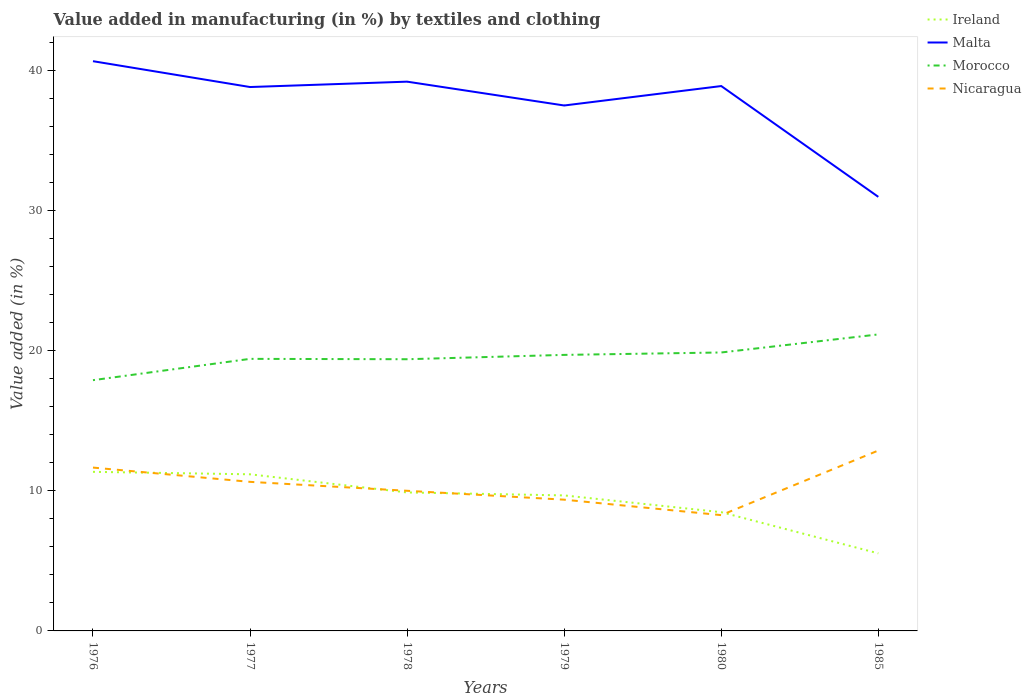How many different coloured lines are there?
Make the answer very short. 4. Does the line corresponding to Ireland intersect with the line corresponding to Malta?
Offer a terse response. No. Is the number of lines equal to the number of legend labels?
Keep it short and to the point. Yes. Across all years, what is the maximum percentage of value added in manufacturing by textiles and clothing in Nicaragua?
Provide a succinct answer. 8.27. In which year was the percentage of value added in manufacturing by textiles and clothing in Ireland maximum?
Ensure brevity in your answer.  1985. What is the total percentage of value added in manufacturing by textiles and clothing in Nicaragua in the graph?
Your response must be concise. 1.74. What is the difference between the highest and the second highest percentage of value added in manufacturing by textiles and clothing in Malta?
Give a very brief answer. 9.69. Does the graph contain any zero values?
Keep it short and to the point. No. Does the graph contain grids?
Your answer should be compact. No. Where does the legend appear in the graph?
Your answer should be compact. Top right. How are the legend labels stacked?
Ensure brevity in your answer.  Vertical. What is the title of the graph?
Your response must be concise. Value added in manufacturing (in %) by textiles and clothing. Does "Benin" appear as one of the legend labels in the graph?
Your answer should be compact. No. What is the label or title of the X-axis?
Provide a succinct answer. Years. What is the label or title of the Y-axis?
Make the answer very short. Value added (in %). What is the Value added (in %) of Ireland in 1976?
Your response must be concise. 11.36. What is the Value added (in %) of Malta in 1976?
Provide a short and direct response. 40.68. What is the Value added (in %) in Morocco in 1976?
Provide a short and direct response. 17.9. What is the Value added (in %) in Nicaragua in 1976?
Your answer should be very brief. 11.66. What is the Value added (in %) in Ireland in 1977?
Give a very brief answer. 11.18. What is the Value added (in %) in Malta in 1977?
Your answer should be very brief. 38.84. What is the Value added (in %) of Morocco in 1977?
Offer a very short reply. 19.43. What is the Value added (in %) of Nicaragua in 1977?
Your response must be concise. 10.64. What is the Value added (in %) in Ireland in 1978?
Make the answer very short. 9.89. What is the Value added (in %) in Malta in 1978?
Your answer should be compact. 39.22. What is the Value added (in %) in Morocco in 1978?
Offer a terse response. 19.4. What is the Value added (in %) in Nicaragua in 1978?
Give a very brief answer. 10.01. What is the Value added (in %) of Ireland in 1979?
Keep it short and to the point. 9.68. What is the Value added (in %) of Malta in 1979?
Your answer should be compact. 37.52. What is the Value added (in %) of Morocco in 1979?
Make the answer very short. 19.71. What is the Value added (in %) in Nicaragua in 1979?
Make the answer very short. 9.37. What is the Value added (in %) in Ireland in 1980?
Offer a very short reply. 8.48. What is the Value added (in %) of Malta in 1980?
Your response must be concise. 38.91. What is the Value added (in %) of Morocco in 1980?
Your response must be concise. 19.88. What is the Value added (in %) of Nicaragua in 1980?
Offer a very short reply. 8.27. What is the Value added (in %) in Ireland in 1985?
Ensure brevity in your answer.  5.54. What is the Value added (in %) in Malta in 1985?
Make the answer very short. 30.99. What is the Value added (in %) of Morocco in 1985?
Provide a succinct answer. 21.17. What is the Value added (in %) of Nicaragua in 1985?
Ensure brevity in your answer.  12.88. Across all years, what is the maximum Value added (in %) in Ireland?
Provide a short and direct response. 11.36. Across all years, what is the maximum Value added (in %) of Malta?
Ensure brevity in your answer.  40.68. Across all years, what is the maximum Value added (in %) in Morocco?
Ensure brevity in your answer.  21.17. Across all years, what is the maximum Value added (in %) in Nicaragua?
Ensure brevity in your answer.  12.88. Across all years, what is the minimum Value added (in %) in Ireland?
Make the answer very short. 5.54. Across all years, what is the minimum Value added (in %) of Malta?
Your response must be concise. 30.99. Across all years, what is the minimum Value added (in %) of Morocco?
Provide a succinct answer. 17.9. Across all years, what is the minimum Value added (in %) of Nicaragua?
Provide a short and direct response. 8.27. What is the total Value added (in %) in Ireland in the graph?
Offer a very short reply. 56.12. What is the total Value added (in %) in Malta in the graph?
Your answer should be compact. 226.15. What is the total Value added (in %) of Morocco in the graph?
Your answer should be compact. 117.49. What is the total Value added (in %) in Nicaragua in the graph?
Your answer should be very brief. 62.83. What is the difference between the Value added (in %) in Ireland in 1976 and that in 1977?
Keep it short and to the point. 0.18. What is the difference between the Value added (in %) in Malta in 1976 and that in 1977?
Give a very brief answer. 1.85. What is the difference between the Value added (in %) of Morocco in 1976 and that in 1977?
Offer a terse response. -1.52. What is the difference between the Value added (in %) of Nicaragua in 1976 and that in 1977?
Your response must be concise. 1.02. What is the difference between the Value added (in %) of Ireland in 1976 and that in 1978?
Your answer should be very brief. 1.47. What is the difference between the Value added (in %) of Malta in 1976 and that in 1978?
Offer a very short reply. 1.46. What is the difference between the Value added (in %) in Morocco in 1976 and that in 1978?
Your answer should be compact. -1.5. What is the difference between the Value added (in %) of Nicaragua in 1976 and that in 1978?
Ensure brevity in your answer.  1.66. What is the difference between the Value added (in %) in Ireland in 1976 and that in 1979?
Provide a succinct answer. 1.68. What is the difference between the Value added (in %) of Malta in 1976 and that in 1979?
Offer a very short reply. 3.16. What is the difference between the Value added (in %) of Morocco in 1976 and that in 1979?
Offer a very short reply. -1.81. What is the difference between the Value added (in %) of Nicaragua in 1976 and that in 1979?
Offer a very short reply. 2.29. What is the difference between the Value added (in %) in Ireland in 1976 and that in 1980?
Your answer should be very brief. 2.88. What is the difference between the Value added (in %) in Malta in 1976 and that in 1980?
Give a very brief answer. 1.78. What is the difference between the Value added (in %) in Morocco in 1976 and that in 1980?
Offer a terse response. -1.98. What is the difference between the Value added (in %) in Nicaragua in 1976 and that in 1980?
Your answer should be compact. 3.39. What is the difference between the Value added (in %) in Ireland in 1976 and that in 1985?
Offer a very short reply. 5.82. What is the difference between the Value added (in %) of Malta in 1976 and that in 1985?
Keep it short and to the point. 9.69. What is the difference between the Value added (in %) in Morocco in 1976 and that in 1985?
Make the answer very short. -3.27. What is the difference between the Value added (in %) of Nicaragua in 1976 and that in 1985?
Keep it short and to the point. -1.22. What is the difference between the Value added (in %) of Ireland in 1977 and that in 1978?
Offer a very short reply. 1.3. What is the difference between the Value added (in %) of Malta in 1977 and that in 1978?
Offer a terse response. -0.38. What is the difference between the Value added (in %) in Morocco in 1977 and that in 1978?
Offer a very short reply. 0.03. What is the difference between the Value added (in %) in Nicaragua in 1977 and that in 1978?
Your answer should be very brief. 0.64. What is the difference between the Value added (in %) in Ireland in 1977 and that in 1979?
Ensure brevity in your answer.  1.51. What is the difference between the Value added (in %) of Malta in 1977 and that in 1979?
Your answer should be compact. 1.32. What is the difference between the Value added (in %) of Morocco in 1977 and that in 1979?
Your response must be concise. -0.28. What is the difference between the Value added (in %) of Nicaragua in 1977 and that in 1979?
Keep it short and to the point. 1.27. What is the difference between the Value added (in %) in Ireland in 1977 and that in 1980?
Give a very brief answer. 2.7. What is the difference between the Value added (in %) in Malta in 1977 and that in 1980?
Offer a terse response. -0.07. What is the difference between the Value added (in %) of Morocco in 1977 and that in 1980?
Your answer should be compact. -0.46. What is the difference between the Value added (in %) of Nicaragua in 1977 and that in 1980?
Make the answer very short. 2.38. What is the difference between the Value added (in %) in Ireland in 1977 and that in 1985?
Provide a short and direct response. 5.64. What is the difference between the Value added (in %) in Malta in 1977 and that in 1985?
Your answer should be very brief. 7.84. What is the difference between the Value added (in %) in Morocco in 1977 and that in 1985?
Provide a short and direct response. -1.74. What is the difference between the Value added (in %) in Nicaragua in 1977 and that in 1985?
Your response must be concise. -2.24. What is the difference between the Value added (in %) of Ireland in 1978 and that in 1979?
Your response must be concise. 0.21. What is the difference between the Value added (in %) in Malta in 1978 and that in 1979?
Your answer should be compact. 1.7. What is the difference between the Value added (in %) in Morocco in 1978 and that in 1979?
Give a very brief answer. -0.31. What is the difference between the Value added (in %) of Nicaragua in 1978 and that in 1979?
Offer a very short reply. 0.64. What is the difference between the Value added (in %) of Ireland in 1978 and that in 1980?
Your response must be concise. 1.41. What is the difference between the Value added (in %) of Malta in 1978 and that in 1980?
Ensure brevity in your answer.  0.31. What is the difference between the Value added (in %) of Morocco in 1978 and that in 1980?
Provide a short and direct response. -0.48. What is the difference between the Value added (in %) in Nicaragua in 1978 and that in 1980?
Ensure brevity in your answer.  1.74. What is the difference between the Value added (in %) in Ireland in 1978 and that in 1985?
Keep it short and to the point. 4.35. What is the difference between the Value added (in %) in Malta in 1978 and that in 1985?
Offer a very short reply. 8.23. What is the difference between the Value added (in %) in Morocco in 1978 and that in 1985?
Your answer should be very brief. -1.77. What is the difference between the Value added (in %) in Nicaragua in 1978 and that in 1985?
Ensure brevity in your answer.  -2.87. What is the difference between the Value added (in %) of Ireland in 1979 and that in 1980?
Keep it short and to the point. 1.2. What is the difference between the Value added (in %) in Malta in 1979 and that in 1980?
Offer a very short reply. -1.39. What is the difference between the Value added (in %) of Morocco in 1979 and that in 1980?
Provide a short and direct response. -0.17. What is the difference between the Value added (in %) in Nicaragua in 1979 and that in 1980?
Your answer should be very brief. 1.1. What is the difference between the Value added (in %) in Ireland in 1979 and that in 1985?
Keep it short and to the point. 4.14. What is the difference between the Value added (in %) in Malta in 1979 and that in 1985?
Give a very brief answer. 6.52. What is the difference between the Value added (in %) in Morocco in 1979 and that in 1985?
Your response must be concise. -1.46. What is the difference between the Value added (in %) of Nicaragua in 1979 and that in 1985?
Provide a short and direct response. -3.51. What is the difference between the Value added (in %) in Ireland in 1980 and that in 1985?
Your response must be concise. 2.94. What is the difference between the Value added (in %) in Malta in 1980 and that in 1985?
Offer a terse response. 7.91. What is the difference between the Value added (in %) in Morocco in 1980 and that in 1985?
Keep it short and to the point. -1.29. What is the difference between the Value added (in %) in Nicaragua in 1980 and that in 1985?
Give a very brief answer. -4.61. What is the difference between the Value added (in %) in Ireland in 1976 and the Value added (in %) in Malta in 1977?
Ensure brevity in your answer.  -27.48. What is the difference between the Value added (in %) in Ireland in 1976 and the Value added (in %) in Morocco in 1977?
Offer a very short reply. -8.07. What is the difference between the Value added (in %) of Ireland in 1976 and the Value added (in %) of Nicaragua in 1977?
Give a very brief answer. 0.72. What is the difference between the Value added (in %) of Malta in 1976 and the Value added (in %) of Morocco in 1977?
Keep it short and to the point. 21.26. What is the difference between the Value added (in %) of Malta in 1976 and the Value added (in %) of Nicaragua in 1977?
Provide a succinct answer. 30.04. What is the difference between the Value added (in %) in Morocco in 1976 and the Value added (in %) in Nicaragua in 1977?
Ensure brevity in your answer.  7.26. What is the difference between the Value added (in %) of Ireland in 1976 and the Value added (in %) of Malta in 1978?
Your response must be concise. -27.86. What is the difference between the Value added (in %) in Ireland in 1976 and the Value added (in %) in Morocco in 1978?
Your response must be concise. -8.04. What is the difference between the Value added (in %) in Ireland in 1976 and the Value added (in %) in Nicaragua in 1978?
Your answer should be very brief. 1.35. What is the difference between the Value added (in %) in Malta in 1976 and the Value added (in %) in Morocco in 1978?
Offer a very short reply. 21.28. What is the difference between the Value added (in %) in Malta in 1976 and the Value added (in %) in Nicaragua in 1978?
Ensure brevity in your answer.  30.67. What is the difference between the Value added (in %) of Morocco in 1976 and the Value added (in %) of Nicaragua in 1978?
Provide a succinct answer. 7.9. What is the difference between the Value added (in %) in Ireland in 1976 and the Value added (in %) in Malta in 1979?
Your answer should be very brief. -26.16. What is the difference between the Value added (in %) of Ireland in 1976 and the Value added (in %) of Morocco in 1979?
Your response must be concise. -8.35. What is the difference between the Value added (in %) of Ireland in 1976 and the Value added (in %) of Nicaragua in 1979?
Offer a very short reply. 1.99. What is the difference between the Value added (in %) of Malta in 1976 and the Value added (in %) of Morocco in 1979?
Make the answer very short. 20.97. What is the difference between the Value added (in %) of Malta in 1976 and the Value added (in %) of Nicaragua in 1979?
Provide a succinct answer. 31.31. What is the difference between the Value added (in %) of Morocco in 1976 and the Value added (in %) of Nicaragua in 1979?
Your response must be concise. 8.53. What is the difference between the Value added (in %) in Ireland in 1976 and the Value added (in %) in Malta in 1980?
Give a very brief answer. -27.55. What is the difference between the Value added (in %) in Ireland in 1976 and the Value added (in %) in Morocco in 1980?
Give a very brief answer. -8.52. What is the difference between the Value added (in %) of Ireland in 1976 and the Value added (in %) of Nicaragua in 1980?
Ensure brevity in your answer.  3.09. What is the difference between the Value added (in %) of Malta in 1976 and the Value added (in %) of Morocco in 1980?
Your response must be concise. 20.8. What is the difference between the Value added (in %) of Malta in 1976 and the Value added (in %) of Nicaragua in 1980?
Your response must be concise. 32.41. What is the difference between the Value added (in %) of Morocco in 1976 and the Value added (in %) of Nicaragua in 1980?
Make the answer very short. 9.64. What is the difference between the Value added (in %) of Ireland in 1976 and the Value added (in %) of Malta in 1985?
Your response must be concise. -19.63. What is the difference between the Value added (in %) of Ireland in 1976 and the Value added (in %) of Morocco in 1985?
Provide a succinct answer. -9.81. What is the difference between the Value added (in %) in Ireland in 1976 and the Value added (in %) in Nicaragua in 1985?
Ensure brevity in your answer.  -1.52. What is the difference between the Value added (in %) in Malta in 1976 and the Value added (in %) in Morocco in 1985?
Provide a short and direct response. 19.51. What is the difference between the Value added (in %) of Malta in 1976 and the Value added (in %) of Nicaragua in 1985?
Ensure brevity in your answer.  27.8. What is the difference between the Value added (in %) of Morocco in 1976 and the Value added (in %) of Nicaragua in 1985?
Your answer should be very brief. 5.02. What is the difference between the Value added (in %) of Ireland in 1977 and the Value added (in %) of Malta in 1978?
Your answer should be very brief. -28.04. What is the difference between the Value added (in %) of Ireland in 1977 and the Value added (in %) of Morocco in 1978?
Your response must be concise. -8.22. What is the difference between the Value added (in %) in Ireland in 1977 and the Value added (in %) in Nicaragua in 1978?
Provide a succinct answer. 1.18. What is the difference between the Value added (in %) of Malta in 1977 and the Value added (in %) of Morocco in 1978?
Offer a terse response. 19.44. What is the difference between the Value added (in %) of Malta in 1977 and the Value added (in %) of Nicaragua in 1978?
Ensure brevity in your answer.  28.83. What is the difference between the Value added (in %) of Morocco in 1977 and the Value added (in %) of Nicaragua in 1978?
Provide a short and direct response. 9.42. What is the difference between the Value added (in %) in Ireland in 1977 and the Value added (in %) in Malta in 1979?
Provide a short and direct response. -26.33. What is the difference between the Value added (in %) in Ireland in 1977 and the Value added (in %) in Morocco in 1979?
Make the answer very short. -8.53. What is the difference between the Value added (in %) in Ireland in 1977 and the Value added (in %) in Nicaragua in 1979?
Provide a succinct answer. 1.81. What is the difference between the Value added (in %) of Malta in 1977 and the Value added (in %) of Morocco in 1979?
Keep it short and to the point. 19.13. What is the difference between the Value added (in %) in Malta in 1977 and the Value added (in %) in Nicaragua in 1979?
Offer a very short reply. 29.46. What is the difference between the Value added (in %) in Morocco in 1977 and the Value added (in %) in Nicaragua in 1979?
Your answer should be very brief. 10.05. What is the difference between the Value added (in %) of Ireland in 1977 and the Value added (in %) of Malta in 1980?
Keep it short and to the point. -27.72. What is the difference between the Value added (in %) of Ireland in 1977 and the Value added (in %) of Morocco in 1980?
Provide a short and direct response. -8.7. What is the difference between the Value added (in %) in Ireland in 1977 and the Value added (in %) in Nicaragua in 1980?
Provide a succinct answer. 2.91. What is the difference between the Value added (in %) of Malta in 1977 and the Value added (in %) of Morocco in 1980?
Ensure brevity in your answer.  18.95. What is the difference between the Value added (in %) in Malta in 1977 and the Value added (in %) in Nicaragua in 1980?
Keep it short and to the point. 30.57. What is the difference between the Value added (in %) in Morocco in 1977 and the Value added (in %) in Nicaragua in 1980?
Offer a terse response. 11.16. What is the difference between the Value added (in %) in Ireland in 1977 and the Value added (in %) in Malta in 1985?
Provide a short and direct response. -19.81. What is the difference between the Value added (in %) in Ireland in 1977 and the Value added (in %) in Morocco in 1985?
Provide a short and direct response. -9.99. What is the difference between the Value added (in %) in Ireland in 1977 and the Value added (in %) in Nicaragua in 1985?
Your response must be concise. -1.7. What is the difference between the Value added (in %) of Malta in 1977 and the Value added (in %) of Morocco in 1985?
Your response must be concise. 17.66. What is the difference between the Value added (in %) in Malta in 1977 and the Value added (in %) in Nicaragua in 1985?
Give a very brief answer. 25.95. What is the difference between the Value added (in %) of Morocco in 1977 and the Value added (in %) of Nicaragua in 1985?
Provide a short and direct response. 6.55. What is the difference between the Value added (in %) in Ireland in 1978 and the Value added (in %) in Malta in 1979?
Your answer should be compact. -27.63. What is the difference between the Value added (in %) of Ireland in 1978 and the Value added (in %) of Morocco in 1979?
Ensure brevity in your answer.  -9.82. What is the difference between the Value added (in %) in Ireland in 1978 and the Value added (in %) in Nicaragua in 1979?
Give a very brief answer. 0.52. What is the difference between the Value added (in %) in Malta in 1978 and the Value added (in %) in Morocco in 1979?
Your answer should be compact. 19.51. What is the difference between the Value added (in %) of Malta in 1978 and the Value added (in %) of Nicaragua in 1979?
Offer a very short reply. 29.85. What is the difference between the Value added (in %) in Morocco in 1978 and the Value added (in %) in Nicaragua in 1979?
Provide a short and direct response. 10.03. What is the difference between the Value added (in %) in Ireland in 1978 and the Value added (in %) in Malta in 1980?
Your answer should be compact. -29.02. What is the difference between the Value added (in %) of Ireland in 1978 and the Value added (in %) of Morocco in 1980?
Make the answer very short. -9.99. What is the difference between the Value added (in %) in Ireland in 1978 and the Value added (in %) in Nicaragua in 1980?
Your answer should be compact. 1.62. What is the difference between the Value added (in %) of Malta in 1978 and the Value added (in %) of Morocco in 1980?
Your response must be concise. 19.34. What is the difference between the Value added (in %) in Malta in 1978 and the Value added (in %) in Nicaragua in 1980?
Keep it short and to the point. 30.95. What is the difference between the Value added (in %) of Morocco in 1978 and the Value added (in %) of Nicaragua in 1980?
Your answer should be compact. 11.13. What is the difference between the Value added (in %) in Ireland in 1978 and the Value added (in %) in Malta in 1985?
Provide a succinct answer. -21.11. What is the difference between the Value added (in %) in Ireland in 1978 and the Value added (in %) in Morocco in 1985?
Offer a terse response. -11.28. What is the difference between the Value added (in %) of Ireland in 1978 and the Value added (in %) of Nicaragua in 1985?
Your answer should be compact. -2.99. What is the difference between the Value added (in %) of Malta in 1978 and the Value added (in %) of Morocco in 1985?
Offer a terse response. 18.05. What is the difference between the Value added (in %) in Malta in 1978 and the Value added (in %) in Nicaragua in 1985?
Offer a very short reply. 26.34. What is the difference between the Value added (in %) of Morocco in 1978 and the Value added (in %) of Nicaragua in 1985?
Offer a very short reply. 6.52. What is the difference between the Value added (in %) of Ireland in 1979 and the Value added (in %) of Malta in 1980?
Give a very brief answer. -29.23. What is the difference between the Value added (in %) in Ireland in 1979 and the Value added (in %) in Morocco in 1980?
Offer a very short reply. -10.21. What is the difference between the Value added (in %) in Ireland in 1979 and the Value added (in %) in Nicaragua in 1980?
Ensure brevity in your answer.  1.41. What is the difference between the Value added (in %) in Malta in 1979 and the Value added (in %) in Morocco in 1980?
Offer a terse response. 17.64. What is the difference between the Value added (in %) of Malta in 1979 and the Value added (in %) of Nicaragua in 1980?
Give a very brief answer. 29.25. What is the difference between the Value added (in %) in Morocco in 1979 and the Value added (in %) in Nicaragua in 1980?
Offer a terse response. 11.44. What is the difference between the Value added (in %) of Ireland in 1979 and the Value added (in %) of Malta in 1985?
Keep it short and to the point. -21.32. What is the difference between the Value added (in %) of Ireland in 1979 and the Value added (in %) of Morocco in 1985?
Provide a short and direct response. -11.5. What is the difference between the Value added (in %) in Ireland in 1979 and the Value added (in %) in Nicaragua in 1985?
Ensure brevity in your answer.  -3.21. What is the difference between the Value added (in %) in Malta in 1979 and the Value added (in %) in Morocco in 1985?
Ensure brevity in your answer.  16.35. What is the difference between the Value added (in %) in Malta in 1979 and the Value added (in %) in Nicaragua in 1985?
Offer a very short reply. 24.64. What is the difference between the Value added (in %) in Morocco in 1979 and the Value added (in %) in Nicaragua in 1985?
Your answer should be compact. 6.83. What is the difference between the Value added (in %) in Ireland in 1980 and the Value added (in %) in Malta in 1985?
Provide a succinct answer. -22.51. What is the difference between the Value added (in %) of Ireland in 1980 and the Value added (in %) of Morocco in 1985?
Give a very brief answer. -12.69. What is the difference between the Value added (in %) of Ireland in 1980 and the Value added (in %) of Nicaragua in 1985?
Your answer should be compact. -4.4. What is the difference between the Value added (in %) in Malta in 1980 and the Value added (in %) in Morocco in 1985?
Your response must be concise. 17.73. What is the difference between the Value added (in %) in Malta in 1980 and the Value added (in %) in Nicaragua in 1985?
Your answer should be compact. 26.02. What is the difference between the Value added (in %) in Morocco in 1980 and the Value added (in %) in Nicaragua in 1985?
Offer a terse response. 7. What is the average Value added (in %) in Ireland per year?
Make the answer very short. 9.35. What is the average Value added (in %) of Malta per year?
Give a very brief answer. 37.69. What is the average Value added (in %) of Morocco per year?
Your response must be concise. 19.58. What is the average Value added (in %) of Nicaragua per year?
Your response must be concise. 10.47. In the year 1976, what is the difference between the Value added (in %) of Ireland and Value added (in %) of Malta?
Provide a short and direct response. -29.32. In the year 1976, what is the difference between the Value added (in %) in Ireland and Value added (in %) in Morocco?
Provide a succinct answer. -6.55. In the year 1976, what is the difference between the Value added (in %) of Ireland and Value added (in %) of Nicaragua?
Provide a short and direct response. -0.3. In the year 1976, what is the difference between the Value added (in %) of Malta and Value added (in %) of Morocco?
Make the answer very short. 22.78. In the year 1976, what is the difference between the Value added (in %) of Malta and Value added (in %) of Nicaragua?
Your answer should be very brief. 29.02. In the year 1976, what is the difference between the Value added (in %) in Morocco and Value added (in %) in Nicaragua?
Give a very brief answer. 6.24. In the year 1977, what is the difference between the Value added (in %) of Ireland and Value added (in %) of Malta?
Your answer should be very brief. -27.65. In the year 1977, what is the difference between the Value added (in %) in Ireland and Value added (in %) in Morocco?
Your response must be concise. -8.24. In the year 1977, what is the difference between the Value added (in %) of Ireland and Value added (in %) of Nicaragua?
Your answer should be very brief. 0.54. In the year 1977, what is the difference between the Value added (in %) of Malta and Value added (in %) of Morocco?
Ensure brevity in your answer.  19.41. In the year 1977, what is the difference between the Value added (in %) in Malta and Value added (in %) in Nicaragua?
Make the answer very short. 28.19. In the year 1977, what is the difference between the Value added (in %) in Morocco and Value added (in %) in Nicaragua?
Offer a very short reply. 8.78. In the year 1978, what is the difference between the Value added (in %) in Ireland and Value added (in %) in Malta?
Your answer should be very brief. -29.33. In the year 1978, what is the difference between the Value added (in %) of Ireland and Value added (in %) of Morocco?
Make the answer very short. -9.51. In the year 1978, what is the difference between the Value added (in %) of Ireland and Value added (in %) of Nicaragua?
Your answer should be compact. -0.12. In the year 1978, what is the difference between the Value added (in %) in Malta and Value added (in %) in Morocco?
Keep it short and to the point. 19.82. In the year 1978, what is the difference between the Value added (in %) in Malta and Value added (in %) in Nicaragua?
Your response must be concise. 29.21. In the year 1978, what is the difference between the Value added (in %) in Morocco and Value added (in %) in Nicaragua?
Your answer should be very brief. 9.39. In the year 1979, what is the difference between the Value added (in %) of Ireland and Value added (in %) of Malta?
Your answer should be compact. -27.84. In the year 1979, what is the difference between the Value added (in %) of Ireland and Value added (in %) of Morocco?
Provide a short and direct response. -10.03. In the year 1979, what is the difference between the Value added (in %) in Ireland and Value added (in %) in Nicaragua?
Your response must be concise. 0.3. In the year 1979, what is the difference between the Value added (in %) of Malta and Value added (in %) of Morocco?
Make the answer very short. 17.81. In the year 1979, what is the difference between the Value added (in %) of Malta and Value added (in %) of Nicaragua?
Keep it short and to the point. 28.15. In the year 1979, what is the difference between the Value added (in %) of Morocco and Value added (in %) of Nicaragua?
Keep it short and to the point. 10.34. In the year 1980, what is the difference between the Value added (in %) in Ireland and Value added (in %) in Malta?
Provide a succinct answer. -30.43. In the year 1980, what is the difference between the Value added (in %) in Ireland and Value added (in %) in Morocco?
Provide a short and direct response. -11.4. In the year 1980, what is the difference between the Value added (in %) of Ireland and Value added (in %) of Nicaragua?
Provide a succinct answer. 0.21. In the year 1980, what is the difference between the Value added (in %) of Malta and Value added (in %) of Morocco?
Keep it short and to the point. 19.02. In the year 1980, what is the difference between the Value added (in %) in Malta and Value added (in %) in Nicaragua?
Offer a terse response. 30.64. In the year 1980, what is the difference between the Value added (in %) in Morocco and Value added (in %) in Nicaragua?
Offer a terse response. 11.61. In the year 1985, what is the difference between the Value added (in %) of Ireland and Value added (in %) of Malta?
Your answer should be compact. -25.45. In the year 1985, what is the difference between the Value added (in %) in Ireland and Value added (in %) in Morocco?
Your answer should be very brief. -15.63. In the year 1985, what is the difference between the Value added (in %) in Ireland and Value added (in %) in Nicaragua?
Ensure brevity in your answer.  -7.34. In the year 1985, what is the difference between the Value added (in %) of Malta and Value added (in %) of Morocco?
Provide a succinct answer. 9.82. In the year 1985, what is the difference between the Value added (in %) in Malta and Value added (in %) in Nicaragua?
Make the answer very short. 18.11. In the year 1985, what is the difference between the Value added (in %) in Morocco and Value added (in %) in Nicaragua?
Your answer should be compact. 8.29. What is the ratio of the Value added (in %) in Ireland in 1976 to that in 1977?
Offer a terse response. 1.02. What is the ratio of the Value added (in %) in Malta in 1976 to that in 1977?
Your answer should be compact. 1.05. What is the ratio of the Value added (in %) in Morocco in 1976 to that in 1977?
Give a very brief answer. 0.92. What is the ratio of the Value added (in %) in Nicaragua in 1976 to that in 1977?
Provide a short and direct response. 1.1. What is the ratio of the Value added (in %) of Ireland in 1976 to that in 1978?
Ensure brevity in your answer.  1.15. What is the ratio of the Value added (in %) in Malta in 1976 to that in 1978?
Your response must be concise. 1.04. What is the ratio of the Value added (in %) of Morocco in 1976 to that in 1978?
Offer a terse response. 0.92. What is the ratio of the Value added (in %) in Nicaragua in 1976 to that in 1978?
Offer a very short reply. 1.17. What is the ratio of the Value added (in %) of Ireland in 1976 to that in 1979?
Your answer should be very brief. 1.17. What is the ratio of the Value added (in %) in Malta in 1976 to that in 1979?
Provide a succinct answer. 1.08. What is the ratio of the Value added (in %) of Morocco in 1976 to that in 1979?
Your response must be concise. 0.91. What is the ratio of the Value added (in %) of Nicaragua in 1976 to that in 1979?
Your answer should be very brief. 1.24. What is the ratio of the Value added (in %) of Ireland in 1976 to that in 1980?
Ensure brevity in your answer.  1.34. What is the ratio of the Value added (in %) in Malta in 1976 to that in 1980?
Offer a very short reply. 1.05. What is the ratio of the Value added (in %) in Morocco in 1976 to that in 1980?
Your answer should be compact. 0.9. What is the ratio of the Value added (in %) in Nicaragua in 1976 to that in 1980?
Ensure brevity in your answer.  1.41. What is the ratio of the Value added (in %) in Ireland in 1976 to that in 1985?
Provide a short and direct response. 2.05. What is the ratio of the Value added (in %) in Malta in 1976 to that in 1985?
Your answer should be very brief. 1.31. What is the ratio of the Value added (in %) in Morocco in 1976 to that in 1985?
Your answer should be very brief. 0.85. What is the ratio of the Value added (in %) in Nicaragua in 1976 to that in 1985?
Provide a short and direct response. 0.91. What is the ratio of the Value added (in %) in Ireland in 1977 to that in 1978?
Keep it short and to the point. 1.13. What is the ratio of the Value added (in %) of Malta in 1977 to that in 1978?
Keep it short and to the point. 0.99. What is the ratio of the Value added (in %) in Morocco in 1977 to that in 1978?
Keep it short and to the point. 1. What is the ratio of the Value added (in %) in Nicaragua in 1977 to that in 1978?
Make the answer very short. 1.06. What is the ratio of the Value added (in %) in Ireland in 1977 to that in 1979?
Your answer should be compact. 1.16. What is the ratio of the Value added (in %) in Malta in 1977 to that in 1979?
Keep it short and to the point. 1.04. What is the ratio of the Value added (in %) in Morocco in 1977 to that in 1979?
Make the answer very short. 0.99. What is the ratio of the Value added (in %) in Nicaragua in 1977 to that in 1979?
Provide a short and direct response. 1.14. What is the ratio of the Value added (in %) in Ireland in 1977 to that in 1980?
Your response must be concise. 1.32. What is the ratio of the Value added (in %) of Morocco in 1977 to that in 1980?
Ensure brevity in your answer.  0.98. What is the ratio of the Value added (in %) of Nicaragua in 1977 to that in 1980?
Provide a succinct answer. 1.29. What is the ratio of the Value added (in %) of Ireland in 1977 to that in 1985?
Provide a short and direct response. 2.02. What is the ratio of the Value added (in %) of Malta in 1977 to that in 1985?
Give a very brief answer. 1.25. What is the ratio of the Value added (in %) of Morocco in 1977 to that in 1985?
Make the answer very short. 0.92. What is the ratio of the Value added (in %) in Nicaragua in 1977 to that in 1985?
Provide a succinct answer. 0.83. What is the ratio of the Value added (in %) of Ireland in 1978 to that in 1979?
Give a very brief answer. 1.02. What is the ratio of the Value added (in %) of Malta in 1978 to that in 1979?
Provide a short and direct response. 1.05. What is the ratio of the Value added (in %) of Morocco in 1978 to that in 1979?
Offer a terse response. 0.98. What is the ratio of the Value added (in %) in Nicaragua in 1978 to that in 1979?
Offer a terse response. 1.07. What is the ratio of the Value added (in %) in Ireland in 1978 to that in 1980?
Offer a terse response. 1.17. What is the ratio of the Value added (in %) in Malta in 1978 to that in 1980?
Offer a very short reply. 1.01. What is the ratio of the Value added (in %) in Morocco in 1978 to that in 1980?
Offer a very short reply. 0.98. What is the ratio of the Value added (in %) of Nicaragua in 1978 to that in 1980?
Provide a succinct answer. 1.21. What is the ratio of the Value added (in %) in Ireland in 1978 to that in 1985?
Provide a short and direct response. 1.79. What is the ratio of the Value added (in %) in Malta in 1978 to that in 1985?
Provide a short and direct response. 1.27. What is the ratio of the Value added (in %) of Morocco in 1978 to that in 1985?
Ensure brevity in your answer.  0.92. What is the ratio of the Value added (in %) of Nicaragua in 1978 to that in 1985?
Your answer should be compact. 0.78. What is the ratio of the Value added (in %) in Ireland in 1979 to that in 1980?
Your answer should be very brief. 1.14. What is the ratio of the Value added (in %) of Malta in 1979 to that in 1980?
Offer a very short reply. 0.96. What is the ratio of the Value added (in %) in Nicaragua in 1979 to that in 1980?
Ensure brevity in your answer.  1.13. What is the ratio of the Value added (in %) of Ireland in 1979 to that in 1985?
Give a very brief answer. 1.75. What is the ratio of the Value added (in %) of Malta in 1979 to that in 1985?
Provide a succinct answer. 1.21. What is the ratio of the Value added (in %) of Morocco in 1979 to that in 1985?
Keep it short and to the point. 0.93. What is the ratio of the Value added (in %) in Nicaragua in 1979 to that in 1985?
Keep it short and to the point. 0.73. What is the ratio of the Value added (in %) of Ireland in 1980 to that in 1985?
Provide a short and direct response. 1.53. What is the ratio of the Value added (in %) in Malta in 1980 to that in 1985?
Offer a terse response. 1.26. What is the ratio of the Value added (in %) in Morocco in 1980 to that in 1985?
Give a very brief answer. 0.94. What is the ratio of the Value added (in %) in Nicaragua in 1980 to that in 1985?
Provide a short and direct response. 0.64. What is the difference between the highest and the second highest Value added (in %) of Ireland?
Ensure brevity in your answer.  0.18. What is the difference between the highest and the second highest Value added (in %) of Malta?
Ensure brevity in your answer.  1.46. What is the difference between the highest and the second highest Value added (in %) in Morocco?
Ensure brevity in your answer.  1.29. What is the difference between the highest and the second highest Value added (in %) in Nicaragua?
Provide a succinct answer. 1.22. What is the difference between the highest and the lowest Value added (in %) in Ireland?
Give a very brief answer. 5.82. What is the difference between the highest and the lowest Value added (in %) in Malta?
Your answer should be compact. 9.69. What is the difference between the highest and the lowest Value added (in %) of Morocco?
Offer a terse response. 3.27. What is the difference between the highest and the lowest Value added (in %) of Nicaragua?
Provide a succinct answer. 4.61. 